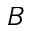<formula> <loc_0><loc_0><loc_500><loc_500>B</formula> 